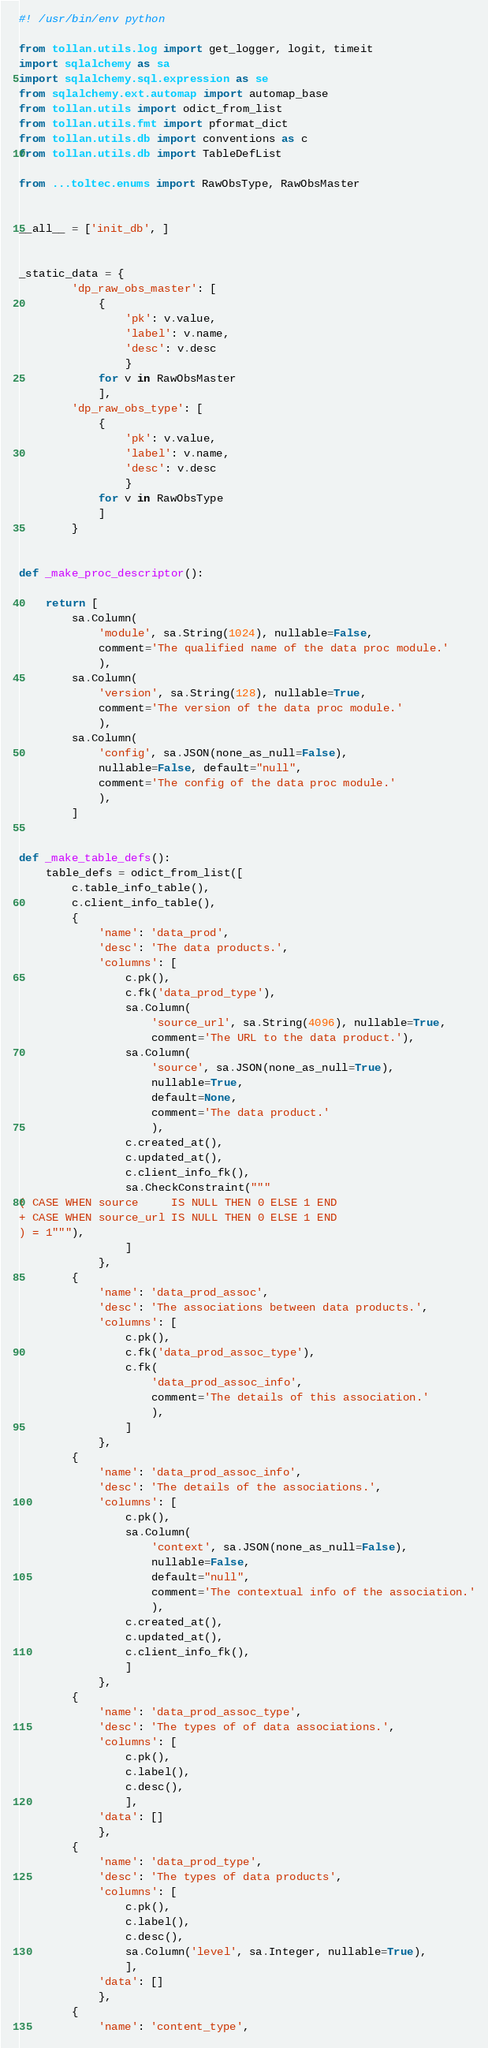<code> <loc_0><loc_0><loc_500><loc_500><_Python_>#! /usr/bin/env python

from tollan.utils.log import get_logger, logit, timeit
import sqlalchemy as sa
import sqlalchemy.sql.expression as se
from sqlalchemy.ext.automap import automap_base
from tollan.utils import odict_from_list
from tollan.utils.fmt import pformat_dict
from tollan.utils.db import conventions as c
from tollan.utils.db import TableDefList

from ...toltec.enums import RawObsType, RawObsMaster


__all__ = ['init_db', ]


_static_data = {
        'dp_raw_obs_master': [
            {
                'pk': v.value,
                'label': v.name,
                'desc': v.desc
                }
            for v in RawObsMaster
            ],
        'dp_raw_obs_type': [
            {
                'pk': v.value,
                'label': v.name,
                'desc': v.desc
                }
            for v in RawObsType
            ]
        }


def _make_proc_descriptor():

    return [
        sa.Column(
            'module', sa.String(1024), nullable=False,
            comment='The qualified name of the data proc module.'
            ),
        sa.Column(
            'version', sa.String(128), nullable=True,
            comment='The version of the data proc module.'
            ),
        sa.Column(
            'config', sa.JSON(none_as_null=False),
            nullable=False, default="null",
            comment='The config of the data proc module.'
            ),
        ]


def _make_table_defs():
    table_defs = odict_from_list([
        c.table_info_table(),
        c.client_info_table(),
        {
            'name': 'data_prod',
            'desc': 'The data products.',
            'columns': [
                c.pk(),
                c.fk('data_prod_type'),
                sa.Column(
                    'source_url', sa.String(4096), nullable=True,
                    comment='The URL to the data product.'),
                sa.Column(
                    'source', sa.JSON(none_as_null=True),
                    nullable=True,
                    default=None,
                    comment='The data product.'
                    ),
                c.created_at(),
                c.updated_at(),
                c.client_info_fk(),
                sa.CheckConstraint("""
( CASE WHEN source     IS NULL THEN 0 ELSE 1 END
+ CASE WHEN source_url IS NULL THEN 0 ELSE 1 END
) = 1"""),
                ]
            },
        {
            'name': 'data_prod_assoc',
            'desc': 'The associations between data products.',
            'columns': [
                c.pk(),
                c.fk('data_prod_assoc_type'),
                c.fk(
                    'data_prod_assoc_info',
                    comment='The details of this association.'
                    ),
                ]
            },
        {
            'name': 'data_prod_assoc_info',
            'desc': 'The details of the associations.',
            'columns': [
                c.pk(),
                sa.Column(
                    'context', sa.JSON(none_as_null=False),
                    nullable=False,
                    default="null",
                    comment='The contextual info of the association.'
                    ),
                c.created_at(),
                c.updated_at(),
                c.client_info_fk(),
                ]
            },
        {
            'name': 'data_prod_assoc_type',
            'desc': 'The types of of data associations.',
            'columns': [
                c.pk(),
                c.label(),
                c.desc(),
                ],
            'data': []
            },
        {
            'name': 'data_prod_type',
            'desc': 'The types of data products',
            'columns': [
                c.pk(),
                c.label(),
                c.desc(),
                sa.Column('level', sa.Integer, nullable=True),
                ],
            'data': []
            },
        {
            'name': 'content_type',</code> 